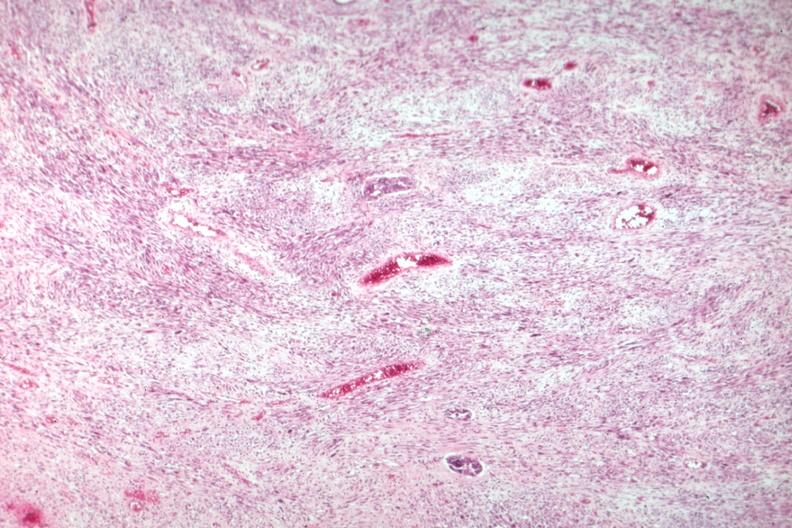what is present?
Answer the question using a single word or phrase. Female reproductive 